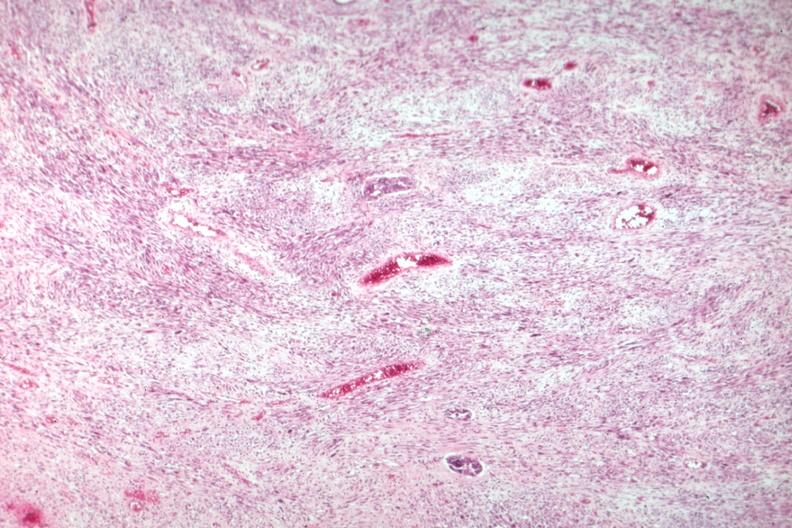what is present?
Answer the question using a single word or phrase. Female reproductive 